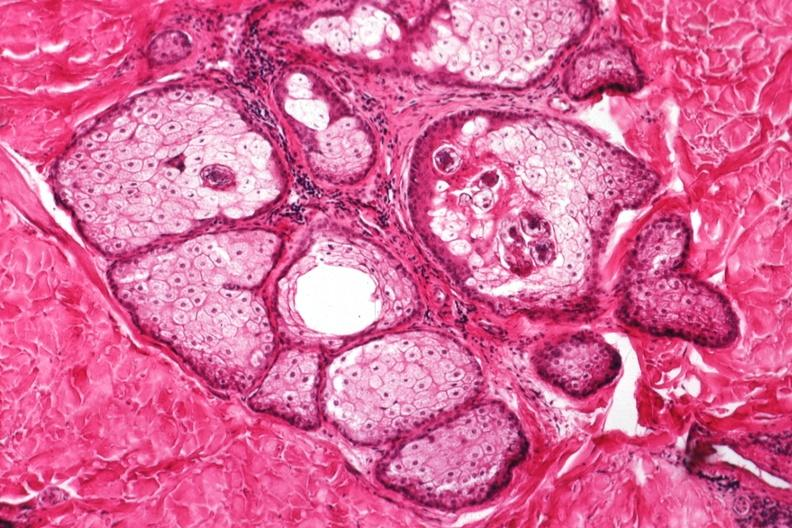what is present?
Answer the question using a single word or phrase. Demodex folliculorum 